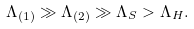<formula> <loc_0><loc_0><loc_500><loc_500>\Lambda _ { ( 1 ) } \gg \Lambda _ { ( 2 ) } \gg \Lambda _ { S } > \Lambda _ { H } .</formula> 